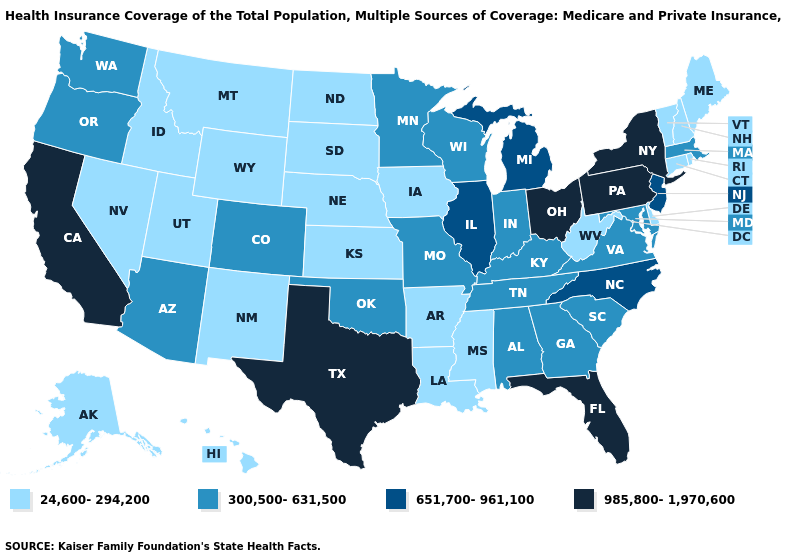Does Idaho have the highest value in the West?
Answer briefly. No. Does Tennessee have a lower value than Massachusetts?
Be succinct. No. Is the legend a continuous bar?
Concise answer only. No. Which states have the lowest value in the West?
Be succinct. Alaska, Hawaii, Idaho, Montana, Nevada, New Mexico, Utah, Wyoming. What is the value of Delaware?
Write a very short answer. 24,600-294,200. Does Idaho have the lowest value in the West?
Quick response, please. Yes. What is the highest value in the USA?
Concise answer only. 985,800-1,970,600. Among the states that border Idaho , does Oregon have the highest value?
Give a very brief answer. Yes. Does Oklahoma have the lowest value in the USA?
Give a very brief answer. No. Name the states that have a value in the range 651,700-961,100?
Keep it brief. Illinois, Michigan, New Jersey, North Carolina. Does Alaska have the lowest value in the USA?
Quick response, please. Yes. Name the states that have a value in the range 985,800-1,970,600?
Be succinct. California, Florida, New York, Ohio, Pennsylvania, Texas. Does Michigan have the lowest value in the USA?
Write a very short answer. No. What is the lowest value in the West?
Answer briefly. 24,600-294,200. 